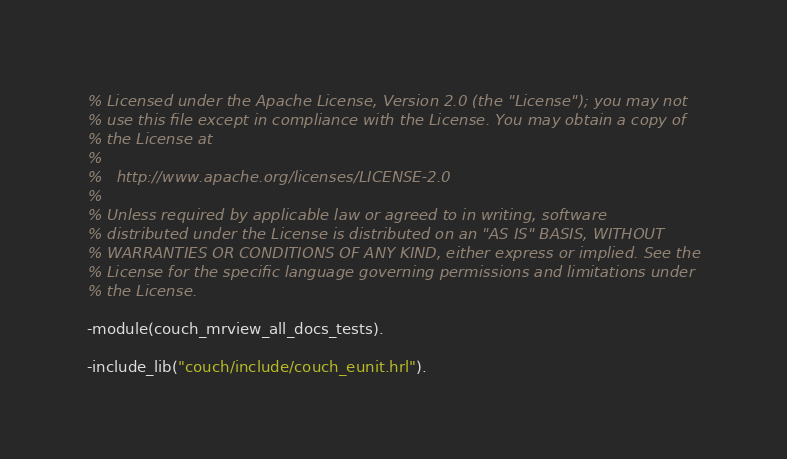<code> <loc_0><loc_0><loc_500><loc_500><_Erlang_>% Licensed under the Apache License, Version 2.0 (the "License"); you may not
% use this file except in compliance with the License. You may obtain a copy of
% the License at
%
%   http://www.apache.org/licenses/LICENSE-2.0
%
% Unless required by applicable law or agreed to in writing, software
% distributed under the License is distributed on an "AS IS" BASIS, WITHOUT
% WARRANTIES OR CONDITIONS OF ANY KIND, either express or implied. See the
% License for the specific language governing permissions and limitations under
% the License.

-module(couch_mrview_all_docs_tests).

-include_lib("couch/include/couch_eunit.hrl").</code> 